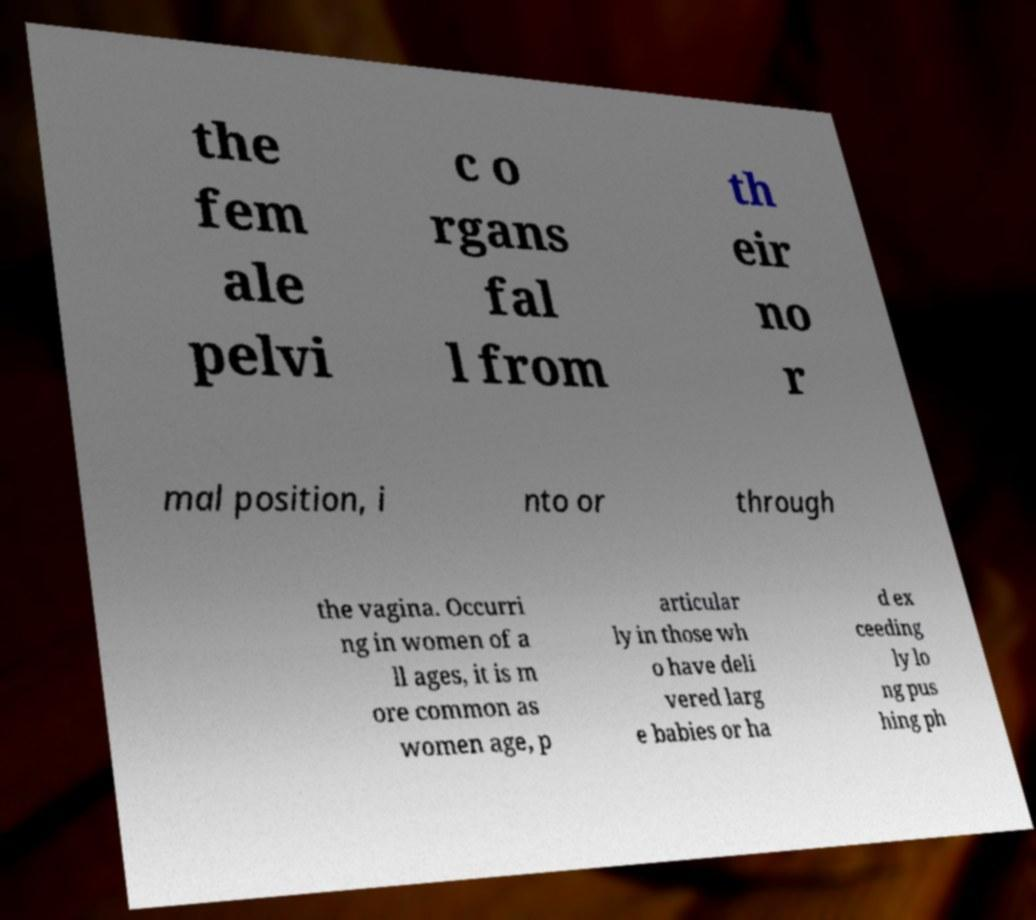Can you read and provide the text displayed in the image?This photo seems to have some interesting text. Can you extract and type it out for me? the fem ale pelvi c o rgans fal l from th eir no r mal position, i nto or through the vagina. Occurri ng in women of a ll ages, it is m ore common as women age, p articular ly in those wh o have deli vered larg e babies or ha d ex ceeding ly lo ng pus hing ph 